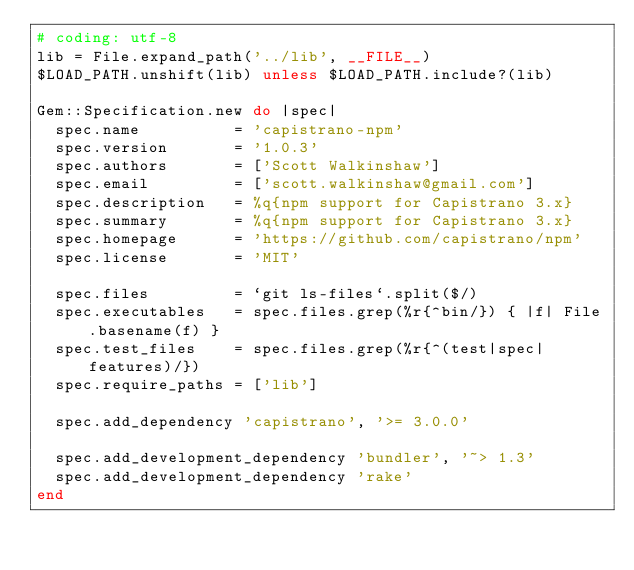Convert code to text. <code><loc_0><loc_0><loc_500><loc_500><_Ruby_># coding: utf-8
lib = File.expand_path('../lib', __FILE__)
$LOAD_PATH.unshift(lib) unless $LOAD_PATH.include?(lib)

Gem::Specification.new do |spec|
  spec.name          = 'capistrano-npm'
  spec.version       = '1.0.3'
  spec.authors       = ['Scott Walkinshaw']
  spec.email         = ['scott.walkinshaw@gmail.com']
  spec.description   = %q{npm support for Capistrano 3.x}
  spec.summary       = %q{npm support for Capistrano 3.x}
  spec.homepage      = 'https://github.com/capistrano/npm'
  spec.license       = 'MIT'

  spec.files         = `git ls-files`.split($/)
  spec.executables   = spec.files.grep(%r{^bin/}) { |f| File.basename(f) }
  spec.test_files    = spec.files.grep(%r{^(test|spec|features)/})
  spec.require_paths = ['lib']

  spec.add_dependency 'capistrano', '>= 3.0.0'

  spec.add_development_dependency 'bundler', '~> 1.3'
  spec.add_development_dependency 'rake'
end
</code> 